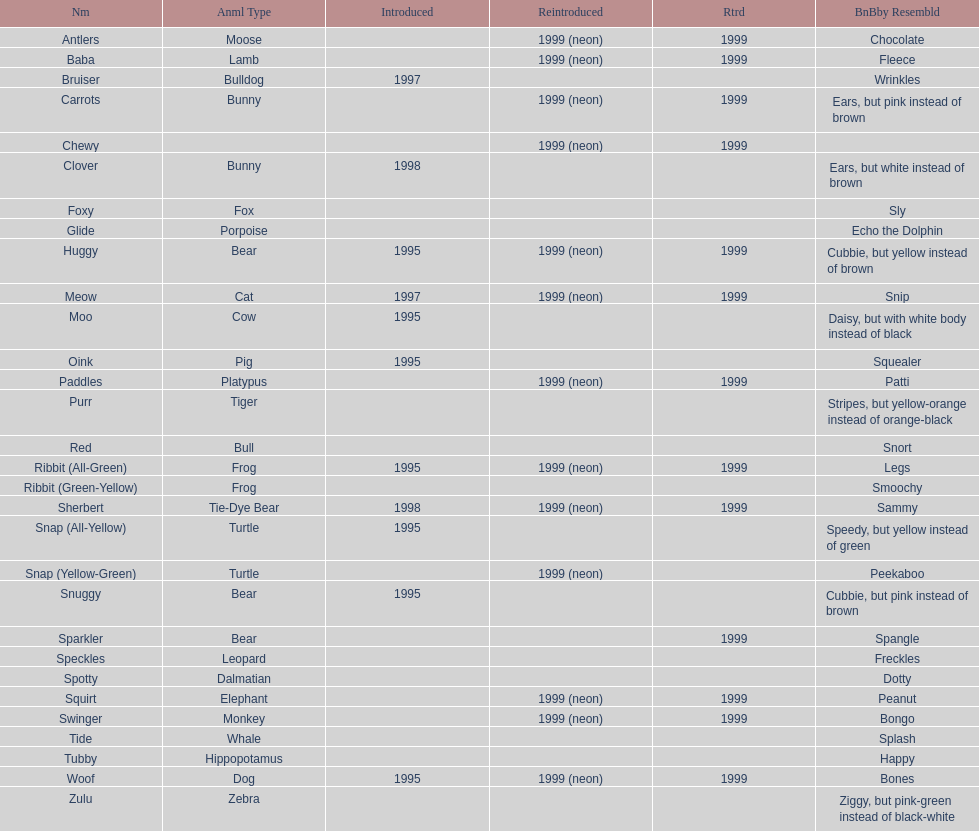How many monkey pillow pals were there? 1. 